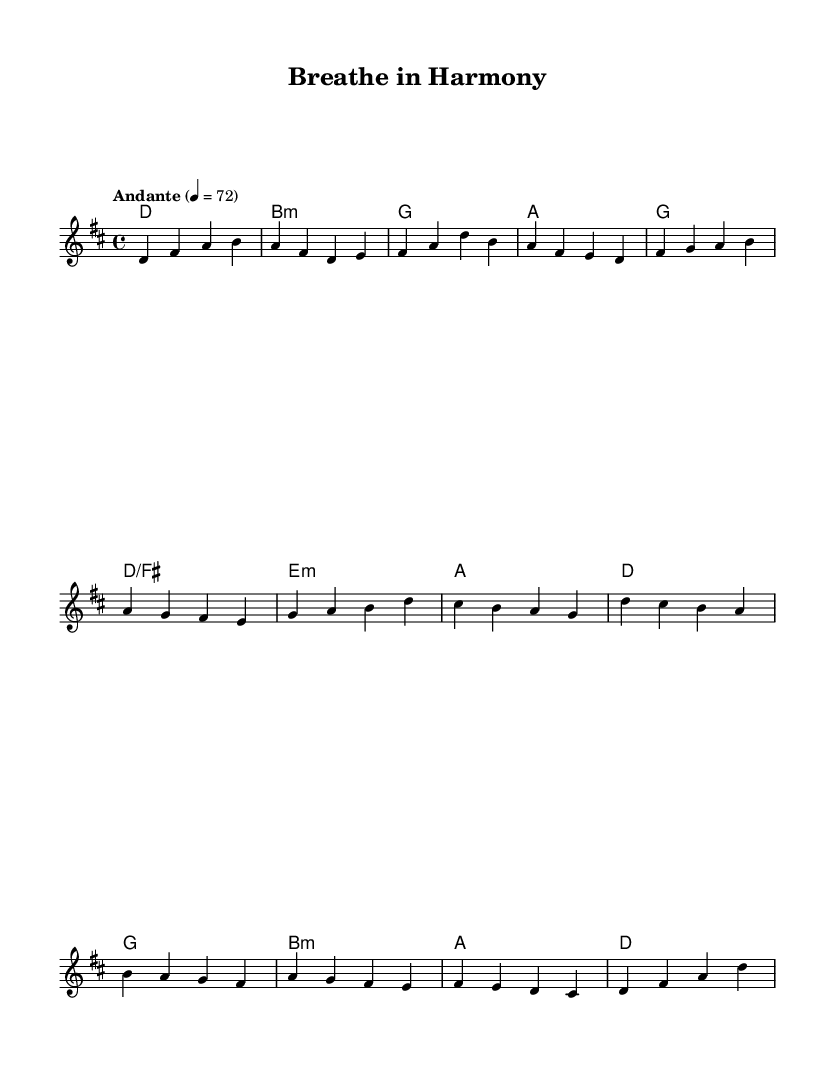What is the key signature of this music? The key signature indicated in the global settings is D major, which contains two sharps (F# and C#).
Answer: D major What is the time signature of this music? The time signature specified is 4/4, which means there are four beats in each measure, and the quarter note gets one beat.
Answer: 4/4 What is the tempo marking? The tempo marking is "Andante," which indicates a moderate speed, typically around 76 to 108 BPM. In this case, it's set at 72 BPM.
Answer: Andante How many measures are in the melody section? The melody is divided into different sections with a total of 12 measures, comprising the Verse (4), Pre-Chorus (4), and Chorus (4).
Answer: 12 Which chord is played during the pre-chorus? The chords listed for the pre-chorus include G major, D over F#, E minor, and A major, in that order.
Answer: G, D/F#, E minor, A What is the last note of the melody? The last note of the melody, as indicated in the score, is a D note, played as the final note in the last measure.
Answer: D What characterizes the ballad style present in this sheet music? The ballad style is characterized by emotional expression, a slower tempo, and a focus on melodic content, making it reflective and introspective in nature.
Answer: Emotional expression, slow tempo 